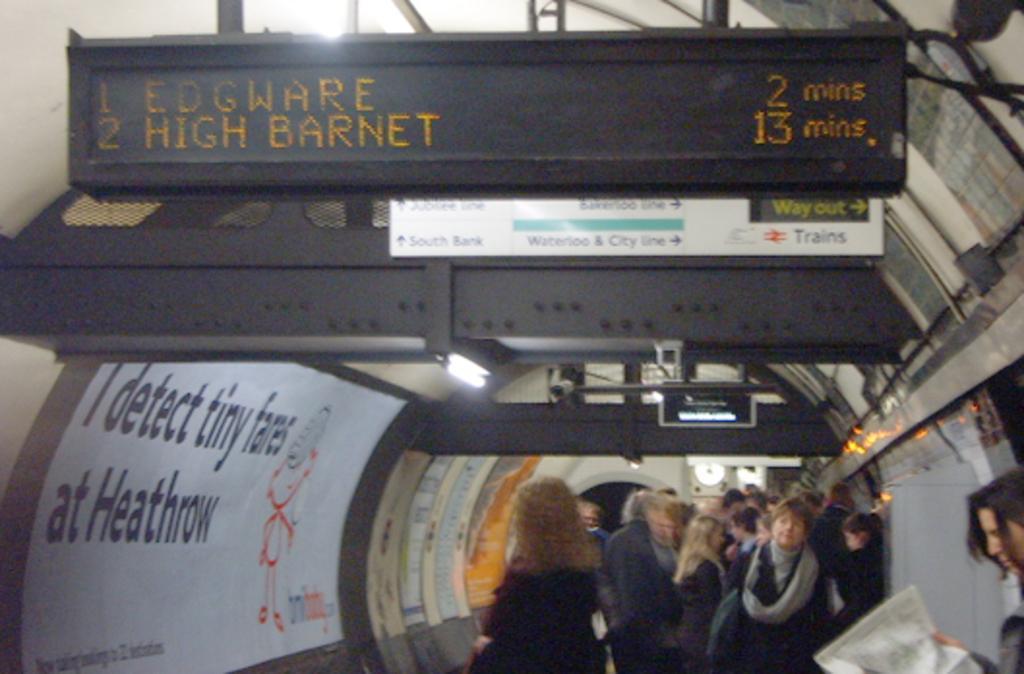Can you describe this image briefly? In this picture I can see there are some persons standing here and on the right side there is a person standing here holding a newspaper and there is a screen here and there is something displayed on it and there is advertisement pasted on the walls of tunnel. 